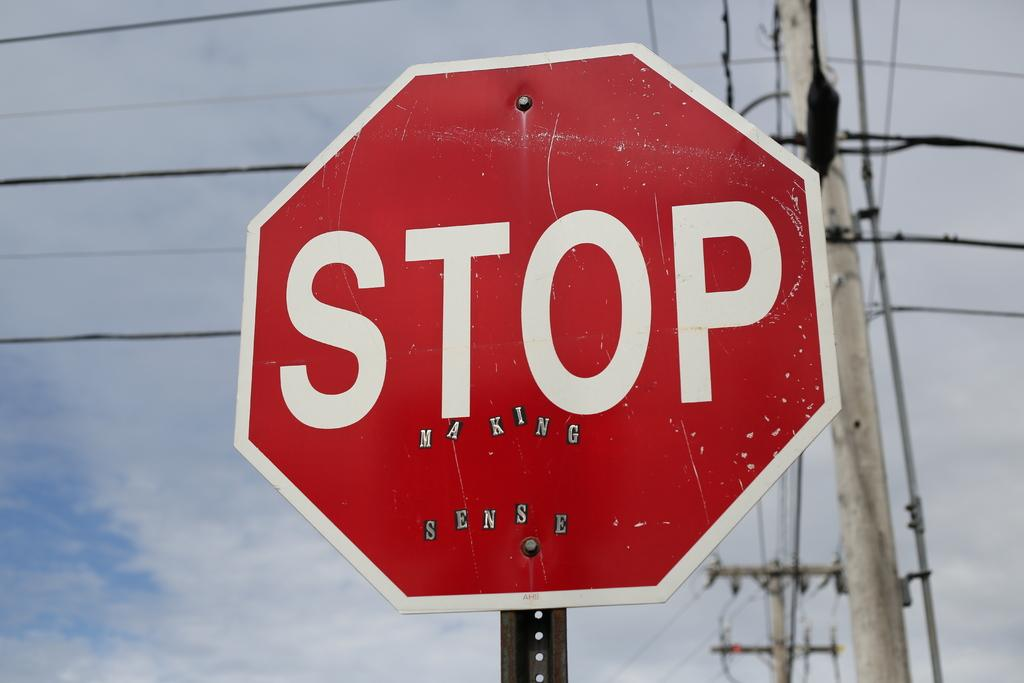<image>
Render a clear and concise summary of the photo. A stop sign in front of some electricity pylons. 